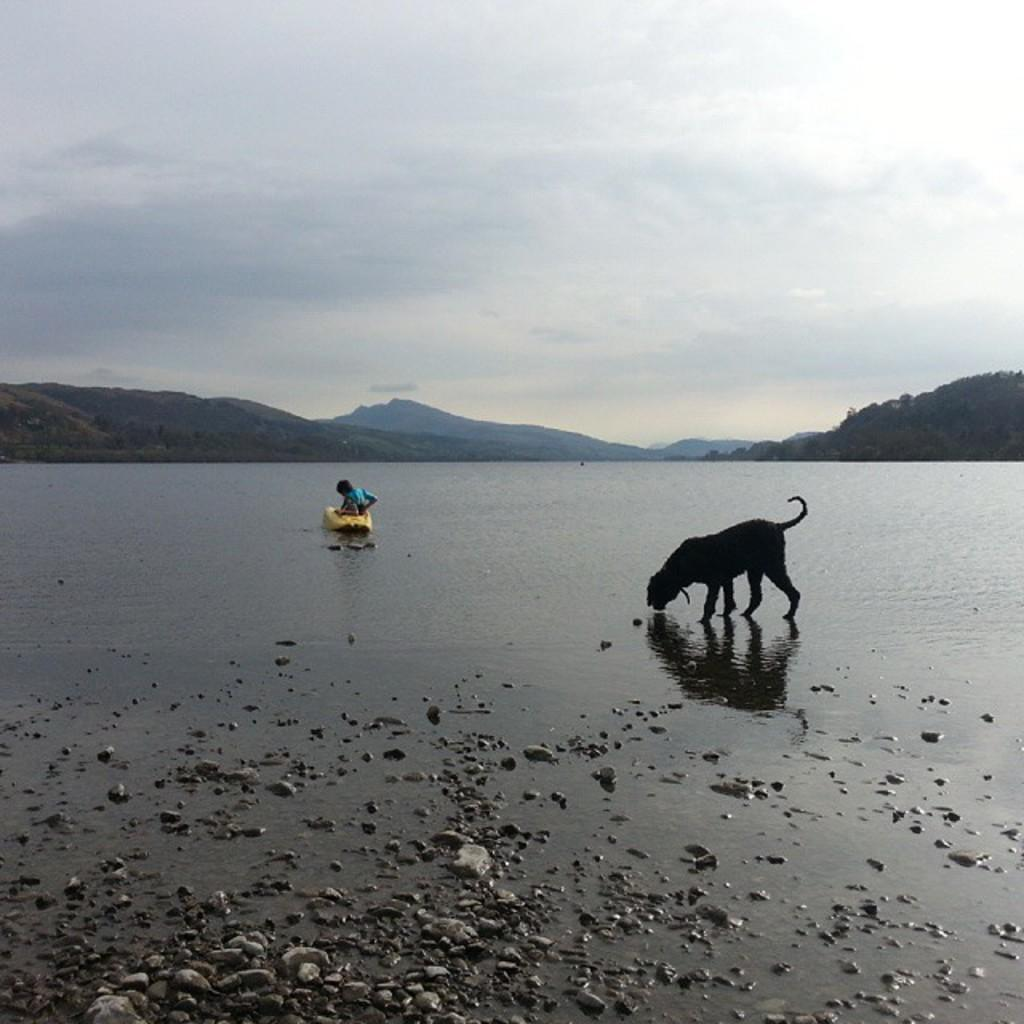What type of setting is depicted in the image? The image is an outside view. What can be seen near the water in the image? There is a dog beside the lake. What geographical feature is located in the middle of the image? There are mountains in the middle of the image. What is visible in the background of the image? The sky is visible in the background of the image. Can you tell me how the kitty is helping the dog beside the lake? There is no kitty present in the image, so it cannot be determined how a kitty might help the dog. 